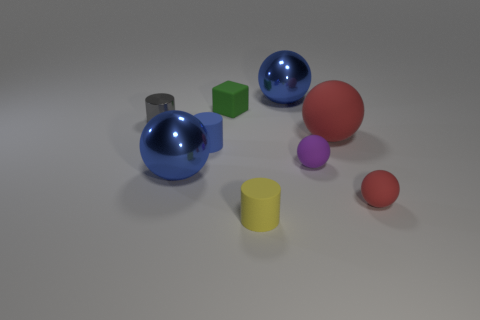Which objects in the image appear to have textures that would be smooth to the touch? Based upon the visual appearance, the objects that would likely feel smooth to touch are the spheres and the cylinders, as they exhibit reflective surfaces indicative of a smooth texture. The large blue and red spheres, the medium-sized red sphere, the smaller purple and red spheres, as well as the grey and yellow cylinders, all show this reflective characteristic. And what about the cubes? The cubes, on the other hand, lack the reflective quality seen in the spheres and cylinders, suggesting a matte texture that might feel less smooth. Both the green and yellow cubes exhibit this matte finish. 